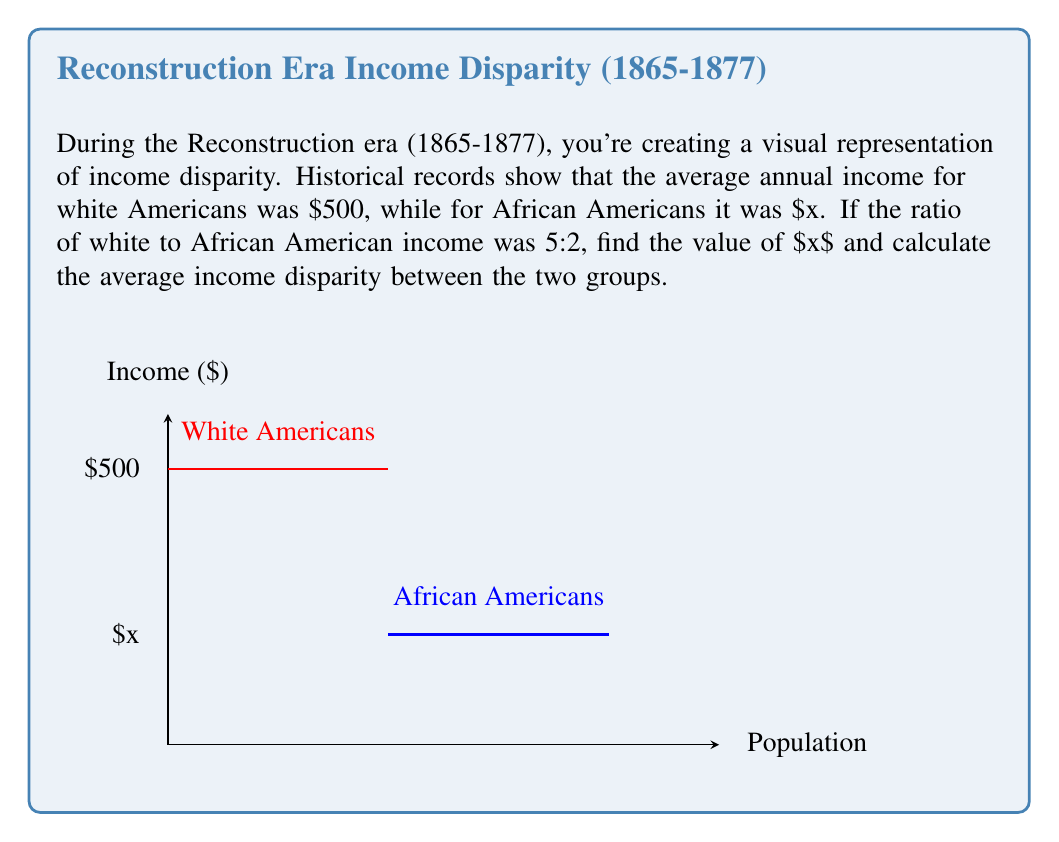Can you answer this question? Let's approach this step-by-step:

1) We're told that the ratio of white to African American income is 5:2. This can be expressed as:

   $$\frac{\text{White income}}{\text{African American income}} = \frac{5}{2}$$

2) We know the white income is $500, so we can set up the equation:

   $$\frac{500}{x} = \frac{5}{2}$$

3) To solve for $x$, we can cross-multiply:

   $$500 \cdot 2 = 5x$$

4) Simplify:

   $$1000 = 5x$$

5) Divide both sides by 5:

   $$200 = x$$

6) Now that we know $x$, we can calculate the income disparity:

   Income disparity = White income - African American income
                    = $500 - $200
                    = $300

7) To find the average income disparity, we don't need to do any additional calculations since we're only comparing two values. The average of a single value is that value itself.
Answer: $300 